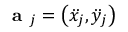Convert formula to latex. <formula><loc_0><loc_0><loc_500><loc_500>a _ { j } = \left ( \ddot { x } _ { j } , \ddot { y } _ { j } \right )</formula> 